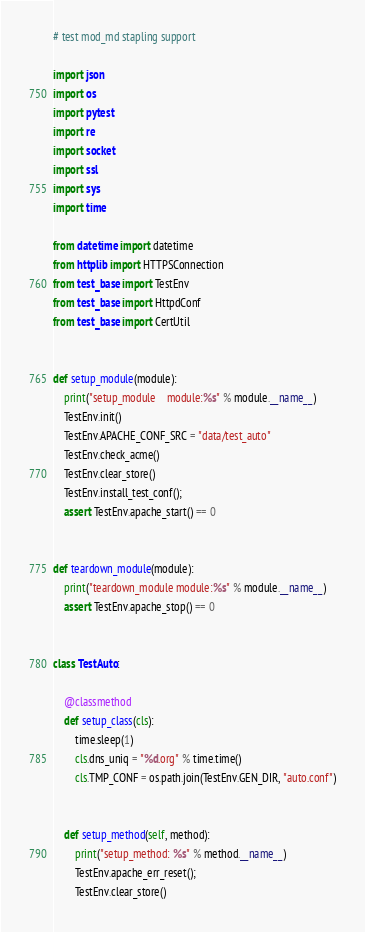Convert code to text. <code><loc_0><loc_0><loc_500><loc_500><_Python_># test mod_md stapling support

import json
import os
import pytest
import re
import socket
import ssl
import sys
import time

from datetime import datetime
from httplib import HTTPSConnection
from test_base import TestEnv
from test_base import HttpdConf
from test_base import CertUtil


def setup_module(module):
    print("setup_module    module:%s" % module.__name__)
    TestEnv.init()
    TestEnv.APACHE_CONF_SRC = "data/test_auto"
    TestEnv.check_acme()
    TestEnv.clear_store()
    TestEnv.install_test_conf();
    assert TestEnv.apache_start() == 0
    

def teardown_module(module):
    print("teardown_module module:%s" % module.__name__)
    assert TestEnv.apache_stop() == 0


class TestAuto:

    @classmethod
    def setup_class(cls):
        time.sleep(1)
        cls.dns_uniq = "%d.org" % time.time()
        cls.TMP_CONF = os.path.join(TestEnv.GEN_DIR, "auto.conf")


    def setup_method(self, method):
        print("setup_method: %s" % method.__name__)
        TestEnv.apache_err_reset();
        TestEnv.clear_store()</code> 